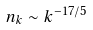Convert formula to latex. <formula><loc_0><loc_0><loc_500><loc_500>n _ { k } \sim k ^ { - 1 7 / 5 }</formula> 